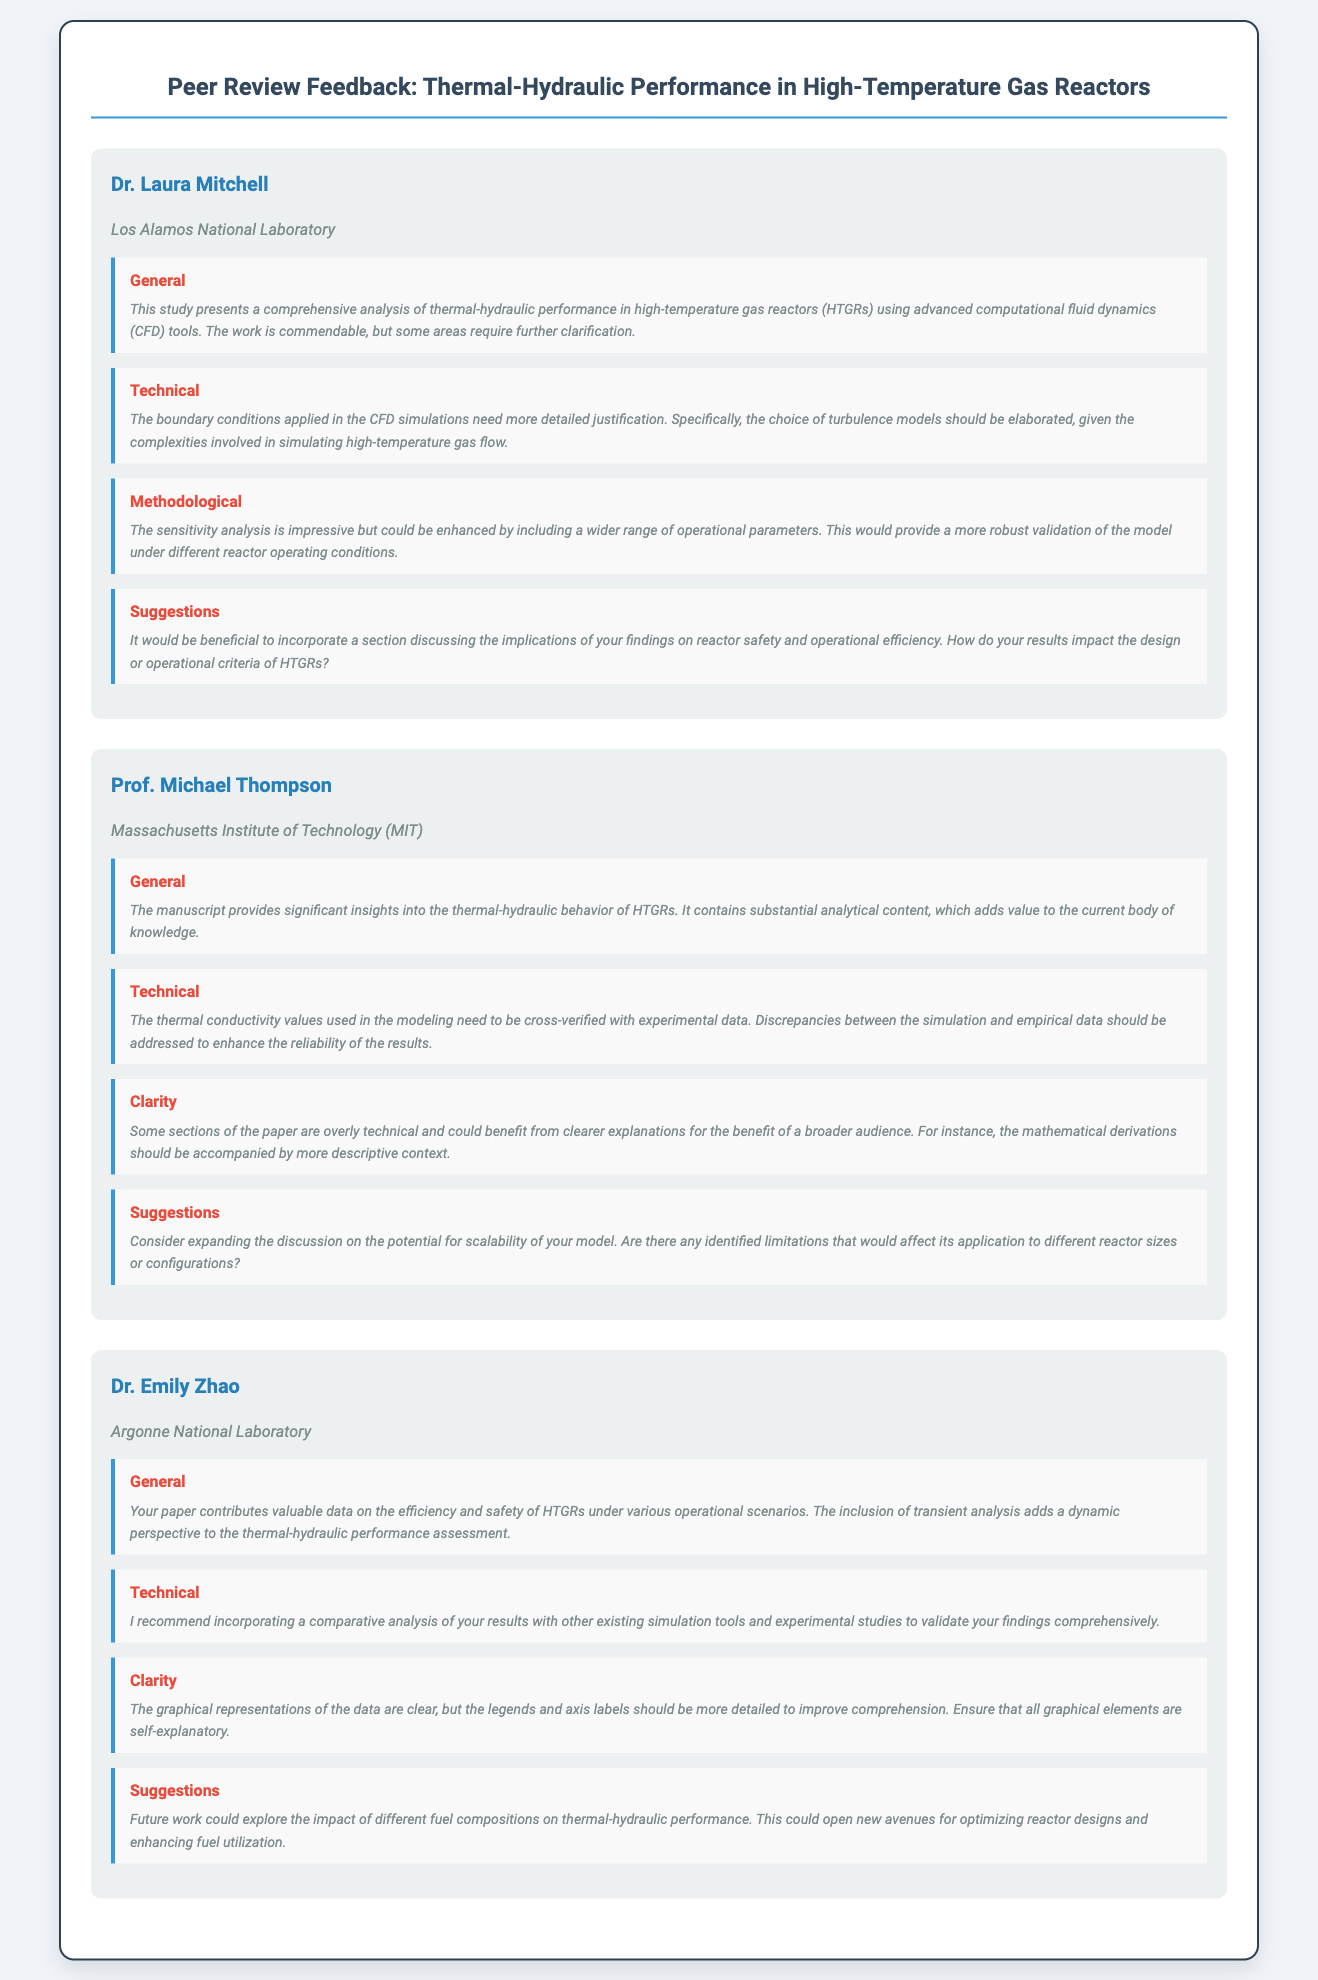What is the title of the publication? The title of the publication is prominently displayed at the top of the document, providing a clear subject reference.
Answer: Peer Review Feedback: Thermal-Hydraulic Performance in High-Temperature Gas Reactors Who is the first reviewer? The first reviewer is introduced with their name and affiliation, serving as an important detail in the review process.
Answer: Dr. Laura Mitchell What institution is Prof. Michael Thompson affiliated with? The affiliation of Prof. Michael Thompson is provided below his name in the reviewer section, indicating his professional background.
Answer: Massachusetts Institute of Technology (MIT) What aspect did Dr. Emily Zhao find valuable in the paper? Dr. Emily Zhao's comment highlights specific contributions of the paper, reflecting the significance of its findings in the field.
Answer: Valuable data on the efficiency and safety of HTGRs What should be included in the sensitivity analysis according to Dr. Laura Mitchell? The suggestion from Dr. Laura Mitchell emphasizes the importance of including various factors to strengthen research validity.
Answer: A wider range of operational parameters What recommendation did Prof. Michael Thompson make regarding thermal conductivity values? Prof. Michael Thompson's feedback addresses the need for cross-verification, demonstrating a quality control measure in research.
Answer: Cross-verified with experimental data What did Dr. Emily Zhao suggest for future work? Dr. Emily Zhao's suggestion encourages further exploration, indicating potential new paths for research and innovation.
Answer: The impact of different fuel compositions on thermal-hydraulic performance Which reviewer's comment discussed the clarity of graphical representations? Clarity feedback is crucial for effective communication of research findings, indicating an area of improvement in the paper.
Answer: Dr. Emily Zhao 